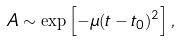Convert formula to latex. <formula><loc_0><loc_0><loc_500><loc_500>A \sim \exp \left [ - \mu ( t - t _ { 0 } ) ^ { 2 } \right ] ,</formula> 